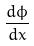Convert formula to latex. <formula><loc_0><loc_0><loc_500><loc_500>\frac { d \phi } { d x }</formula> 